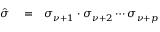Convert formula to latex. <formula><loc_0><loc_0><loc_500><loc_500>\begin{array} { r l r } { \hat { \sigma } } & = } & { \sigma _ { \nu + 1 } \cdot \sigma _ { \nu + 2 } \cdots \sigma _ { \nu + p } } \end{array}</formula> 